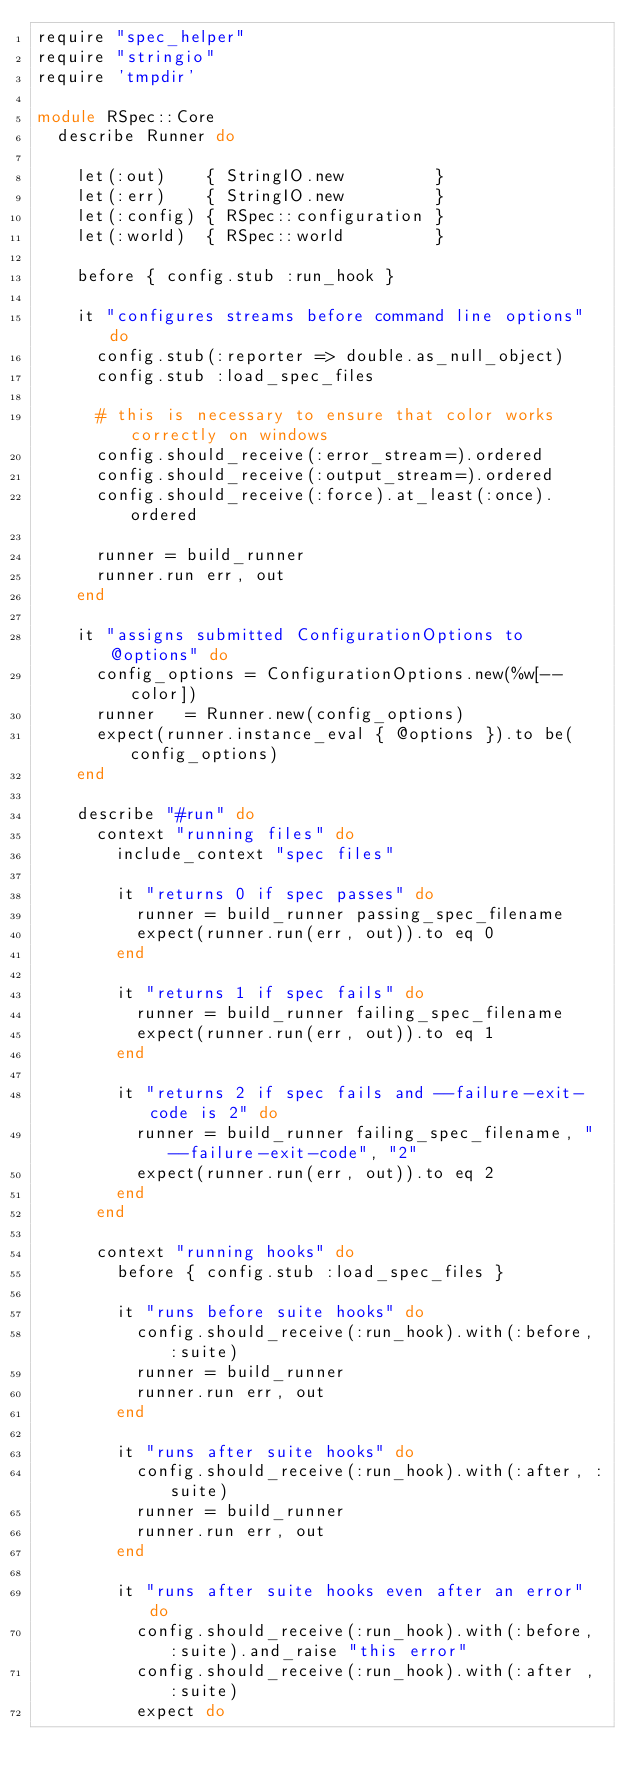<code> <loc_0><loc_0><loc_500><loc_500><_Ruby_>require "spec_helper"
require "stringio"
require 'tmpdir'

module RSpec::Core
  describe Runner do

    let(:out)    { StringIO.new         }
    let(:err)    { StringIO.new         }
    let(:config) { RSpec::configuration }
    let(:world)  { RSpec::world         }

    before { config.stub :run_hook }

    it "configures streams before command line options" do
      config.stub(:reporter => double.as_null_object)
      config.stub :load_spec_files

      # this is necessary to ensure that color works correctly on windows
      config.should_receive(:error_stream=).ordered
      config.should_receive(:output_stream=).ordered
      config.should_receive(:force).at_least(:once).ordered

      runner = build_runner
      runner.run err, out
    end

    it "assigns submitted ConfigurationOptions to @options" do
      config_options = ConfigurationOptions.new(%w[--color])
      runner   = Runner.new(config_options)
      expect(runner.instance_eval { @options }).to be(config_options)
    end

    describe "#run" do
      context "running files" do
        include_context "spec files"

        it "returns 0 if spec passes" do
          runner = build_runner passing_spec_filename
          expect(runner.run(err, out)).to eq 0
        end

        it "returns 1 if spec fails" do
          runner = build_runner failing_spec_filename
          expect(runner.run(err, out)).to eq 1
        end

        it "returns 2 if spec fails and --failure-exit-code is 2" do
          runner = build_runner failing_spec_filename, "--failure-exit-code", "2"
          expect(runner.run(err, out)).to eq 2
        end
      end

      context "running hooks" do
        before { config.stub :load_spec_files }

        it "runs before suite hooks" do
          config.should_receive(:run_hook).with(:before, :suite)
          runner = build_runner
          runner.run err, out
        end

        it "runs after suite hooks" do
          config.should_receive(:run_hook).with(:after, :suite)
          runner = build_runner
          runner.run err, out
        end

        it "runs after suite hooks even after an error" do
          config.should_receive(:run_hook).with(:before, :suite).and_raise "this error"
          config.should_receive(:run_hook).with(:after , :suite)
          expect do</code> 